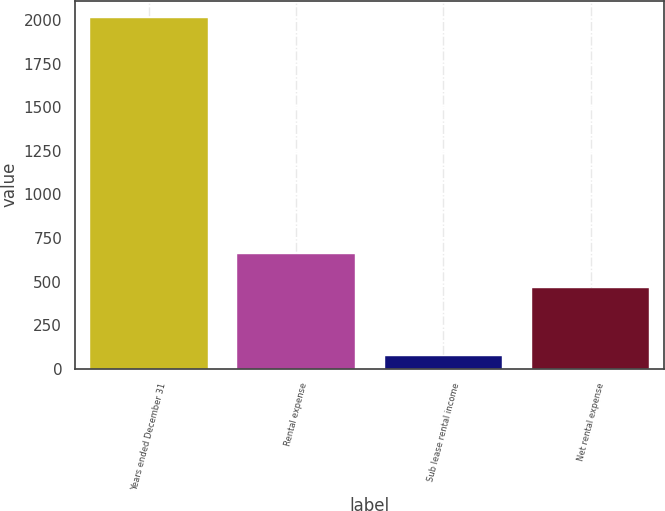Convert chart. <chart><loc_0><loc_0><loc_500><loc_500><bar_chart><fcel>Years ended December 31<fcel>Rental expense<fcel>Sub lease rental income<fcel>Net rental expense<nl><fcel>2012<fcel>658<fcel>72<fcel>464<nl></chart> 